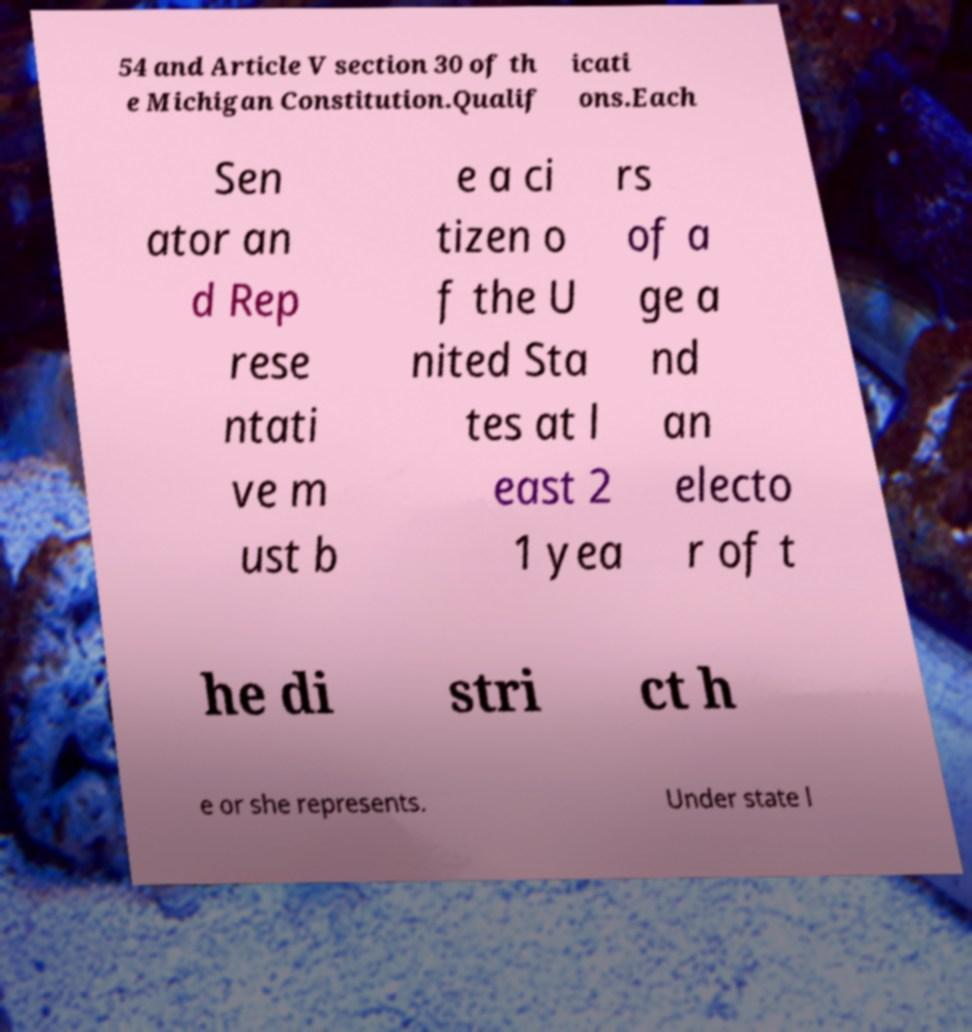Please identify and transcribe the text found in this image. 54 and Article V section 30 of th e Michigan Constitution.Qualif icati ons.Each Sen ator an d Rep rese ntati ve m ust b e a ci tizen o f the U nited Sta tes at l east 2 1 yea rs of a ge a nd an electo r of t he di stri ct h e or she represents. Under state l 